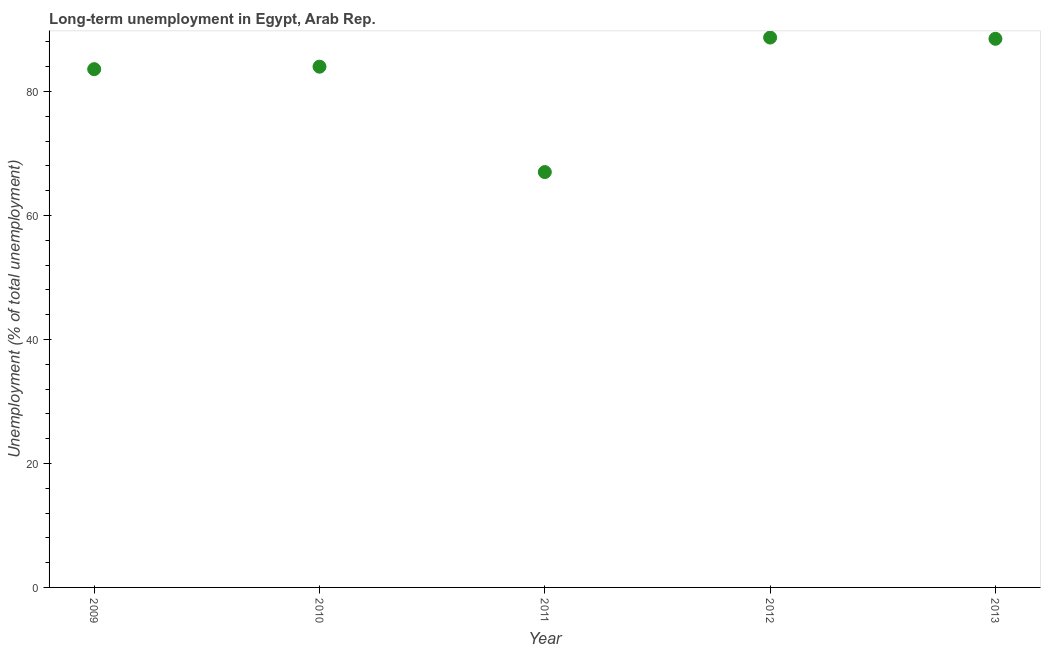What is the long-term unemployment in 2013?
Give a very brief answer. 88.5. Across all years, what is the maximum long-term unemployment?
Keep it short and to the point. 88.7. Across all years, what is the minimum long-term unemployment?
Ensure brevity in your answer.  67. What is the sum of the long-term unemployment?
Your response must be concise. 411.8. What is the difference between the long-term unemployment in 2011 and 2013?
Your answer should be compact. -21.5. What is the average long-term unemployment per year?
Ensure brevity in your answer.  82.36. In how many years, is the long-term unemployment greater than 64 %?
Give a very brief answer. 5. Do a majority of the years between 2013 and 2011 (inclusive) have long-term unemployment greater than 24 %?
Your response must be concise. No. What is the ratio of the long-term unemployment in 2012 to that in 2013?
Ensure brevity in your answer.  1. Is the difference between the long-term unemployment in 2009 and 2012 greater than the difference between any two years?
Provide a short and direct response. No. What is the difference between the highest and the second highest long-term unemployment?
Provide a succinct answer. 0.2. Is the sum of the long-term unemployment in 2012 and 2013 greater than the maximum long-term unemployment across all years?
Provide a succinct answer. Yes. What is the difference between the highest and the lowest long-term unemployment?
Your answer should be very brief. 21.7. How many dotlines are there?
Your response must be concise. 1. How many years are there in the graph?
Your answer should be compact. 5. Are the values on the major ticks of Y-axis written in scientific E-notation?
Keep it short and to the point. No. Does the graph contain any zero values?
Your response must be concise. No. What is the title of the graph?
Make the answer very short. Long-term unemployment in Egypt, Arab Rep. What is the label or title of the Y-axis?
Your answer should be compact. Unemployment (% of total unemployment). What is the Unemployment (% of total unemployment) in 2009?
Give a very brief answer. 83.6. What is the Unemployment (% of total unemployment) in 2010?
Your response must be concise. 84. What is the Unemployment (% of total unemployment) in 2012?
Your answer should be very brief. 88.7. What is the Unemployment (% of total unemployment) in 2013?
Offer a terse response. 88.5. What is the difference between the Unemployment (% of total unemployment) in 2009 and 2010?
Your answer should be compact. -0.4. What is the difference between the Unemployment (% of total unemployment) in 2009 and 2011?
Your answer should be compact. 16.6. What is the difference between the Unemployment (% of total unemployment) in 2010 and 2012?
Provide a succinct answer. -4.7. What is the difference between the Unemployment (% of total unemployment) in 2011 and 2012?
Provide a short and direct response. -21.7. What is the difference between the Unemployment (% of total unemployment) in 2011 and 2013?
Ensure brevity in your answer.  -21.5. What is the difference between the Unemployment (% of total unemployment) in 2012 and 2013?
Offer a terse response. 0.2. What is the ratio of the Unemployment (% of total unemployment) in 2009 to that in 2010?
Provide a succinct answer. 0.99. What is the ratio of the Unemployment (% of total unemployment) in 2009 to that in 2011?
Give a very brief answer. 1.25. What is the ratio of the Unemployment (% of total unemployment) in 2009 to that in 2012?
Ensure brevity in your answer.  0.94. What is the ratio of the Unemployment (% of total unemployment) in 2009 to that in 2013?
Make the answer very short. 0.94. What is the ratio of the Unemployment (% of total unemployment) in 2010 to that in 2011?
Your response must be concise. 1.25. What is the ratio of the Unemployment (% of total unemployment) in 2010 to that in 2012?
Your answer should be compact. 0.95. What is the ratio of the Unemployment (% of total unemployment) in 2010 to that in 2013?
Your response must be concise. 0.95. What is the ratio of the Unemployment (% of total unemployment) in 2011 to that in 2012?
Provide a succinct answer. 0.76. What is the ratio of the Unemployment (% of total unemployment) in 2011 to that in 2013?
Offer a terse response. 0.76. 